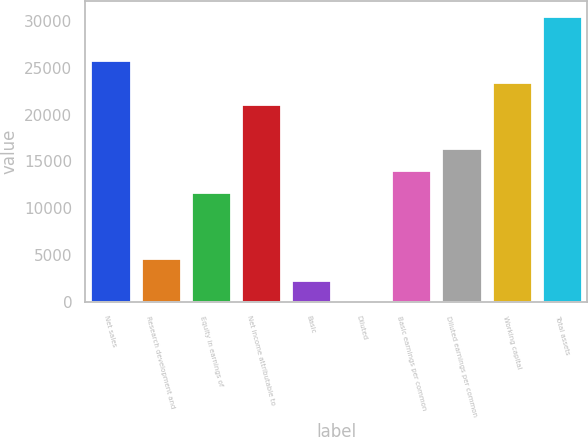Convert chart to OTSL. <chart><loc_0><loc_0><loc_500><loc_500><bar_chart><fcel>Net sales<fcel>Research development and<fcel>Equity in earnings of<fcel>Net income attributable to<fcel>Basic<fcel>Diluted<fcel>Basic earnings per common<fcel>Diluted earnings per common<fcel>Working capital<fcel>Total assets<nl><fcel>25849.8<fcel>4701.02<fcel>11750.6<fcel>21150.1<fcel>2351.15<fcel>1.28<fcel>14100.5<fcel>16450.4<fcel>23500<fcel>30549.6<nl></chart> 